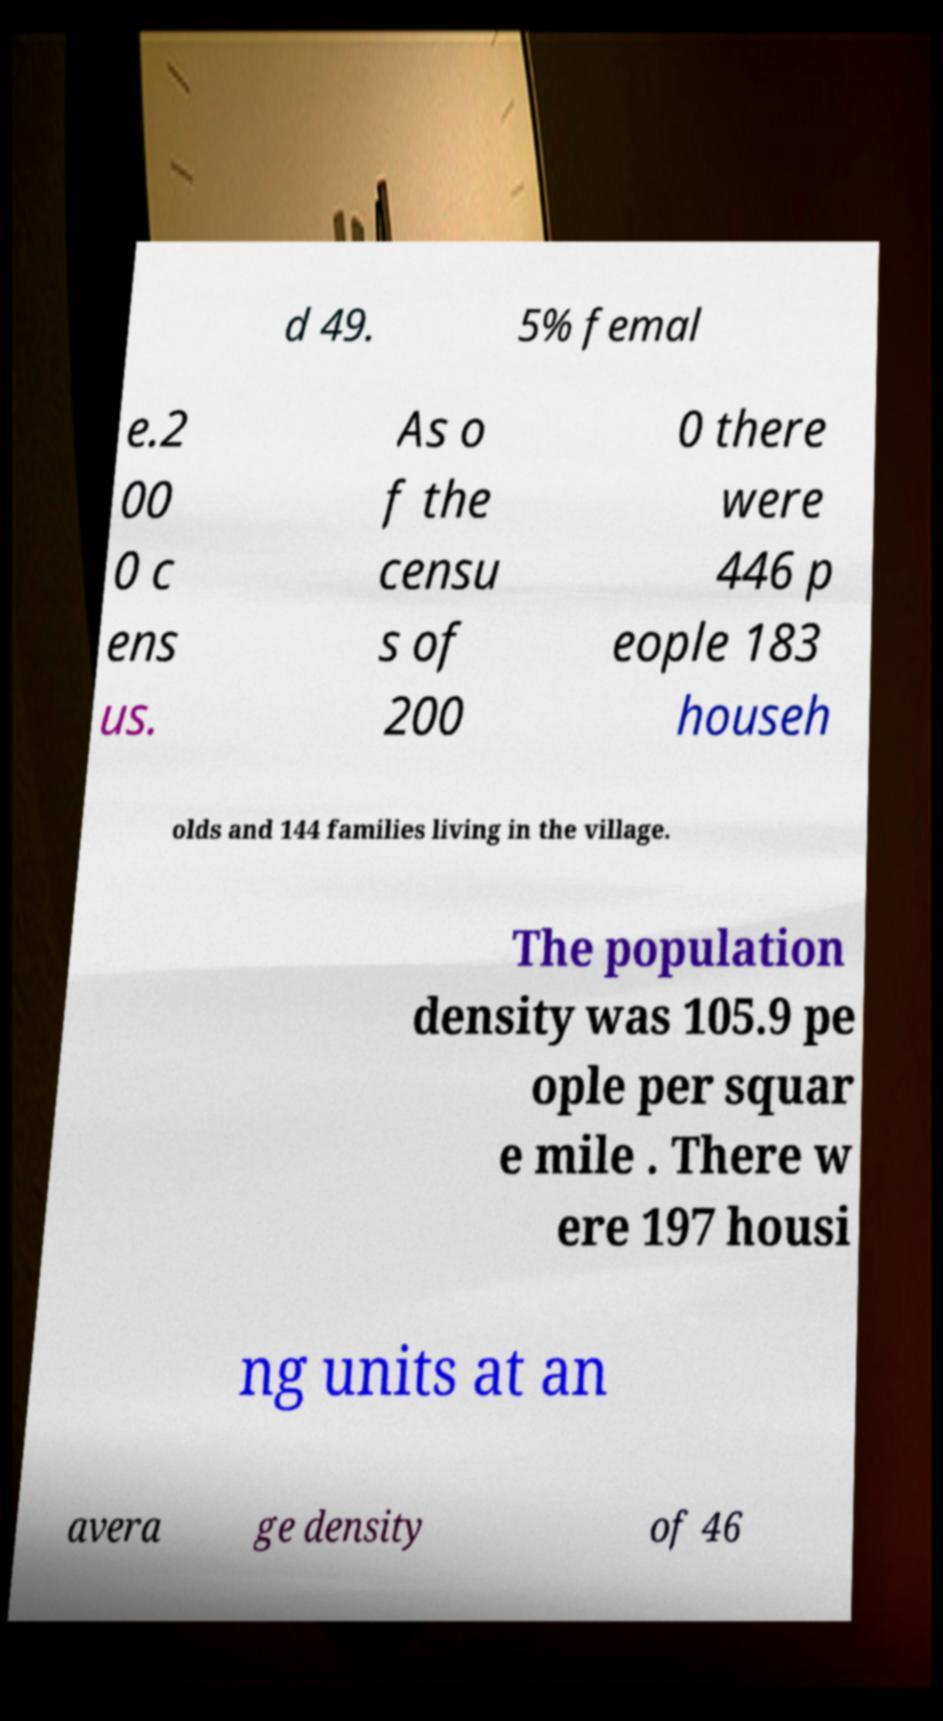Could you extract and type out the text from this image? d 49. 5% femal e.2 00 0 c ens us. As o f the censu s of 200 0 there were 446 p eople 183 househ olds and 144 families living in the village. The population density was 105.9 pe ople per squar e mile . There w ere 197 housi ng units at an avera ge density of 46 